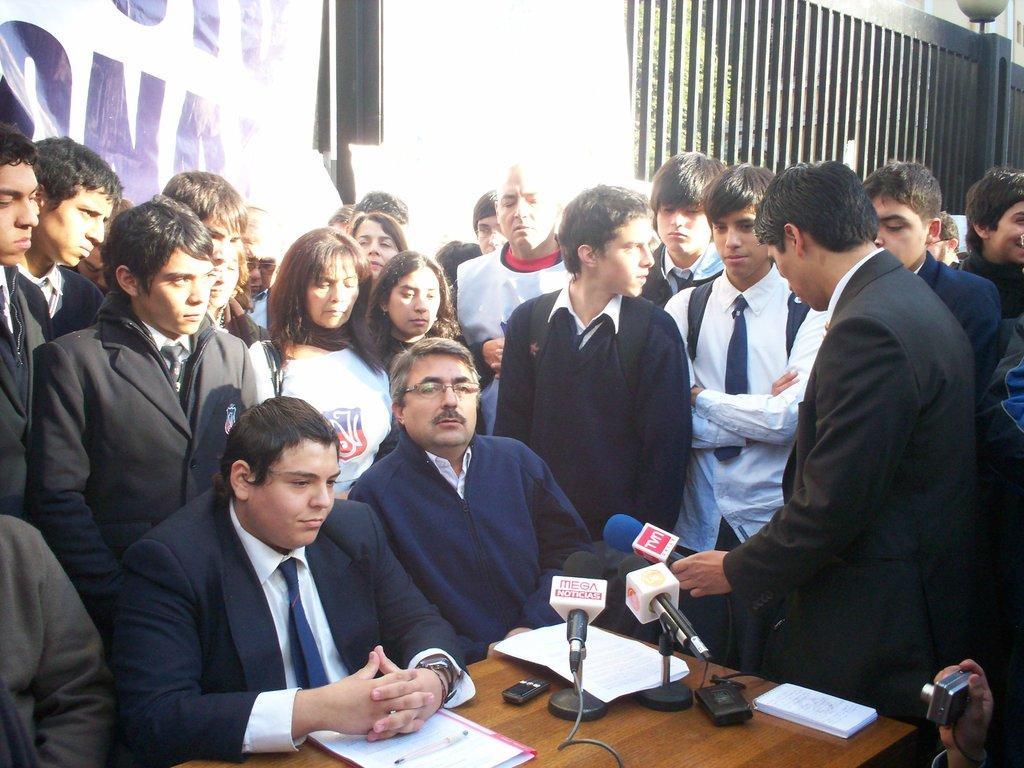In one or two sentences, can you explain what this image depicts? In this picture we can see some people standing in the background, there are two persons sitting in front of a table, we can see microphones, papers, a file and a book present on the table, this man is holding a mike. 